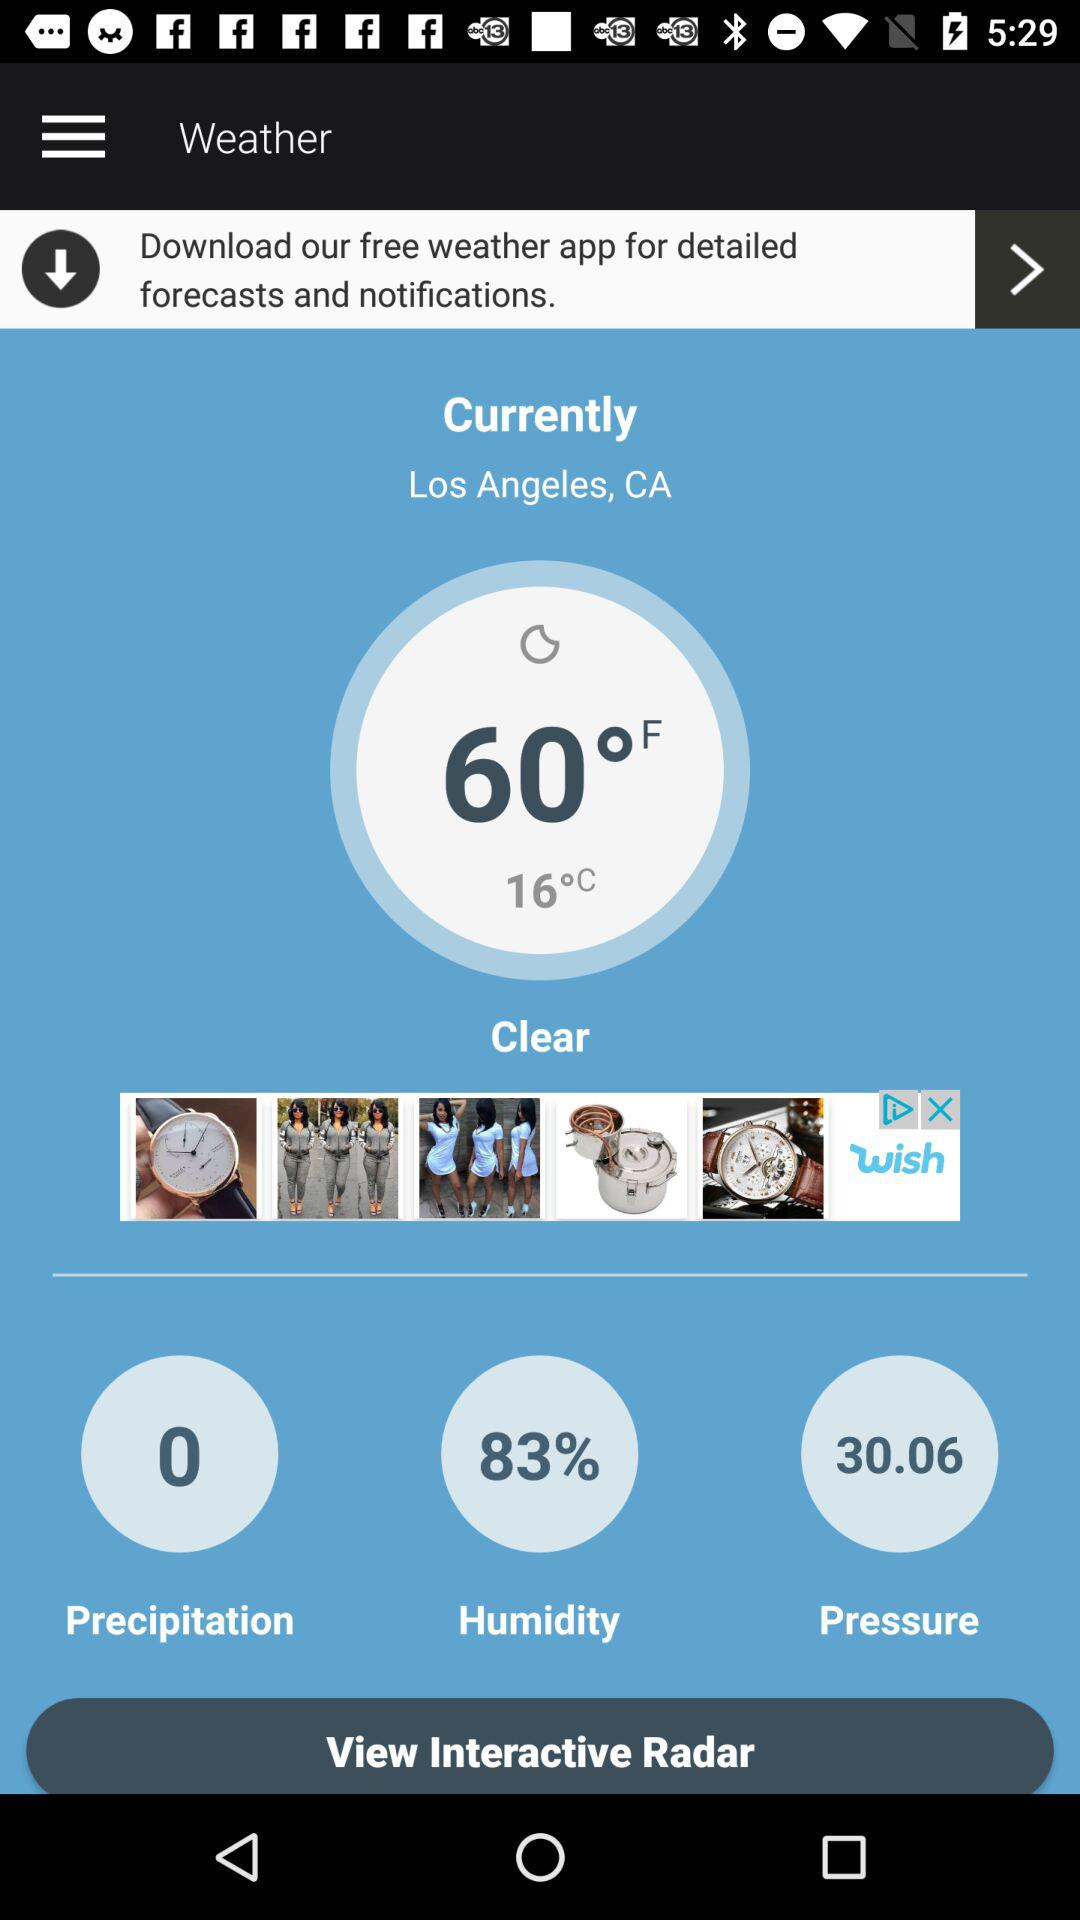Which setting has a value of 30.06? The setting that has a value of 30.06 is "Pressure". 